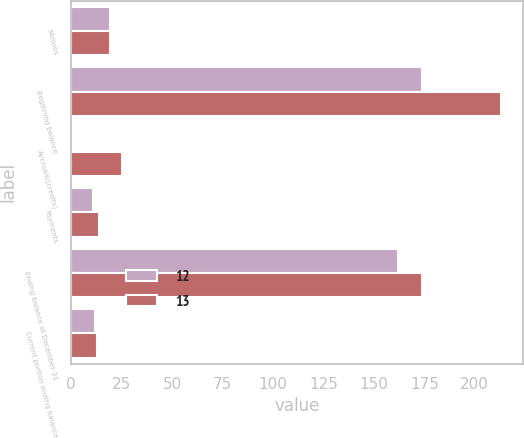Convert chart. <chart><loc_0><loc_0><loc_500><loc_500><stacked_bar_chart><ecel><fcel>Millions<fcel>Beginning balance<fcel>Accruals/(credits)<fcel>Payments<fcel>Ending balance at December 31<fcel>Current portion ending balance<nl><fcel>12<fcel>19.5<fcel>174<fcel>1<fcel>11<fcel>162<fcel>12<nl><fcel>13<fcel>19.5<fcel>213<fcel>25<fcel>14<fcel>174<fcel>13<nl></chart> 